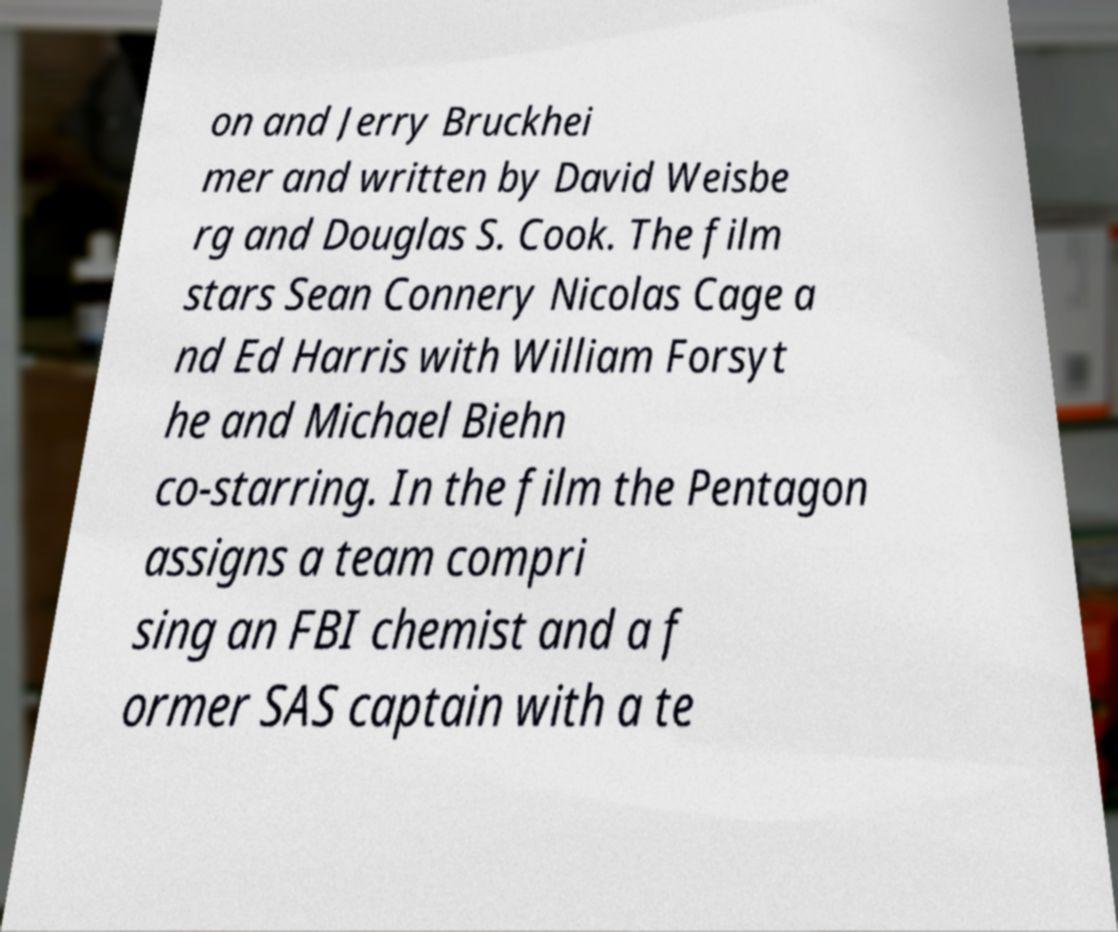I need the written content from this picture converted into text. Can you do that? on and Jerry Bruckhei mer and written by David Weisbe rg and Douglas S. Cook. The film stars Sean Connery Nicolas Cage a nd Ed Harris with William Forsyt he and Michael Biehn co-starring. In the film the Pentagon assigns a team compri sing an FBI chemist and a f ormer SAS captain with a te 